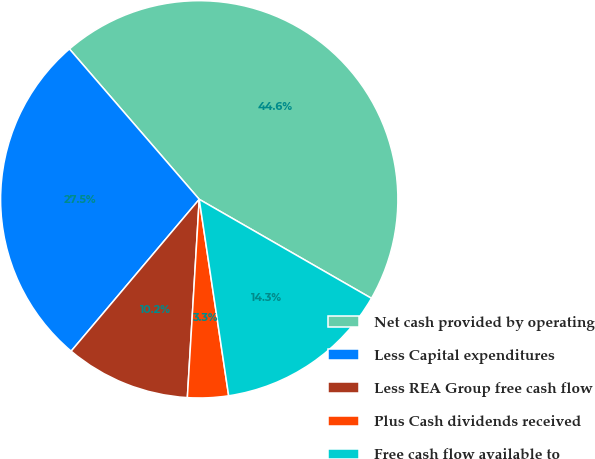Convert chart. <chart><loc_0><loc_0><loc_500><loc_500><pie_chart><fcel>Net cash provided by operating<fcel>Less Capital expenditures<fcel>Less REA Group free cash flow<fcel>Plus Cash dividends received<fcel>Free cash flow available to<nl><fcel>44.64%<fcel>27.51%<fcel>10.2%<fcel>3.32%<fcel>14.33%<nl></chart> 